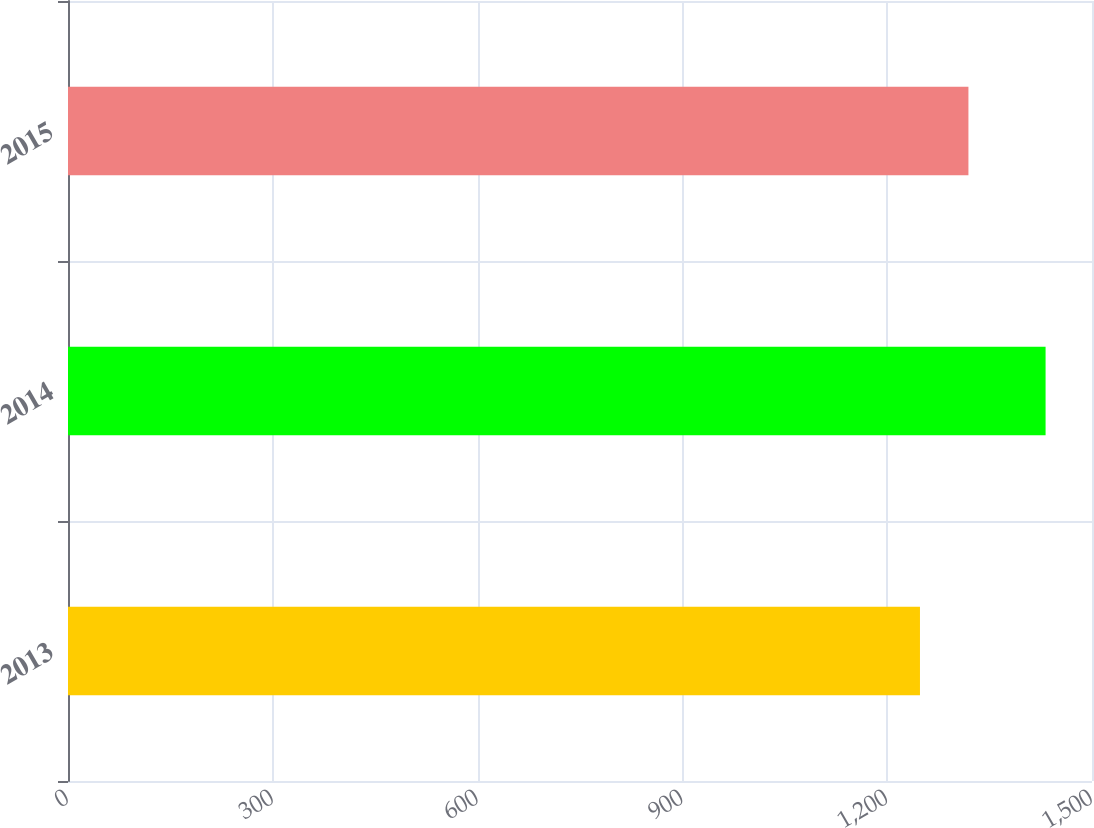<chart> <loc_0><loc_0><loc_500><loc_500><bar_chart><fcel>2013<fcel>2014<fcel>2015<nl><fcel>1248<fcel>1432<fcel>1319<nl></chart> 